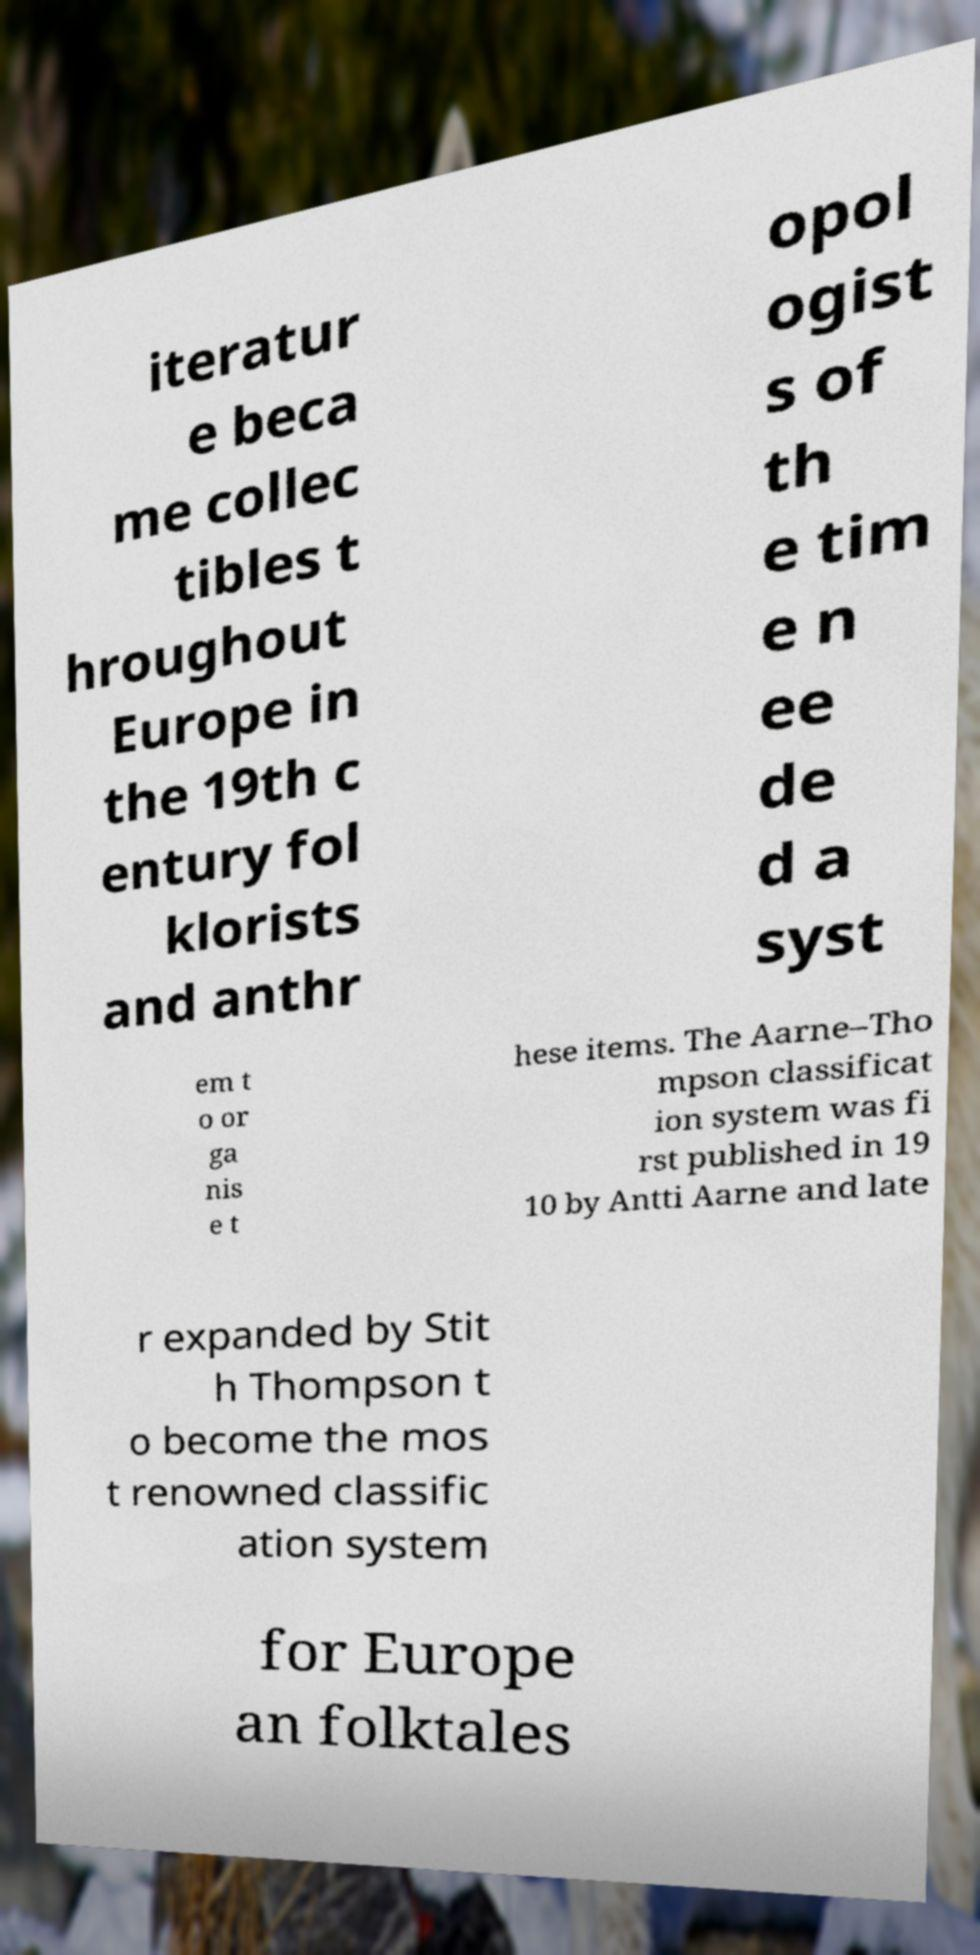There's text embedded in this image that I need extracted. Can you transcribe it verbatim? iteratur e beca me collec tibles t hroughout Europe in the 19th c entury fol klorists and anthr opol ogist s of th e tim e n ee de d a syst em t o or ga nis e t hese items. The Aarne–Tho mpson classificat ion system was fi rst published in 19 10 by Antti Aarne and late r expanded by Stit h Thompson t o become the mos t renowned classific ation system for Europe an folktales 